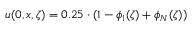Convert formula to latex. <formula><loc_0><loc_0><loc_500><loc_500>u ( 0 , x , \zeta ) = 0 . 2 5 \cdot ( 1 - \phi _ { 1 } ( \zeta ) + \phi _ { N } ( \zeta ) )</formula> 